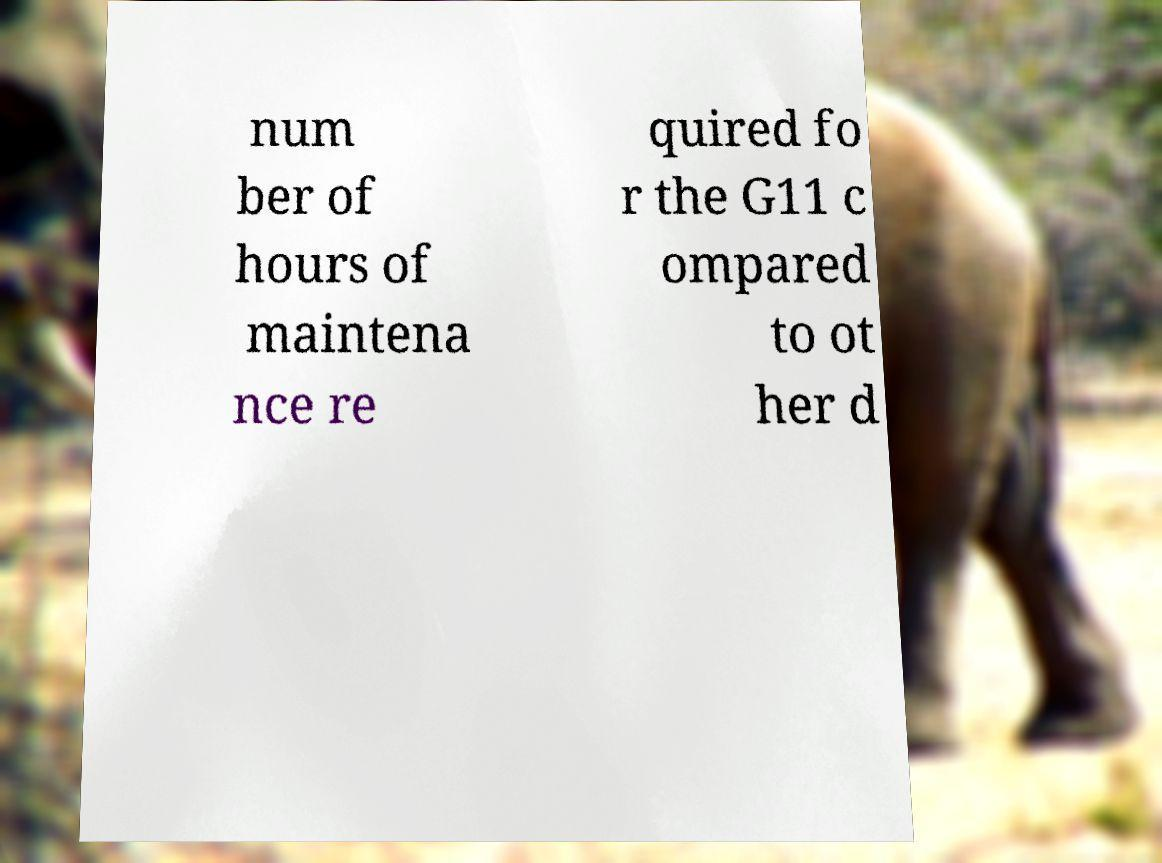For documentation purposes, I need the text within this image transcribed. Could you provide that? num ber of hours of maintena nce re quired fo r the G11 c ompared to ot her d 